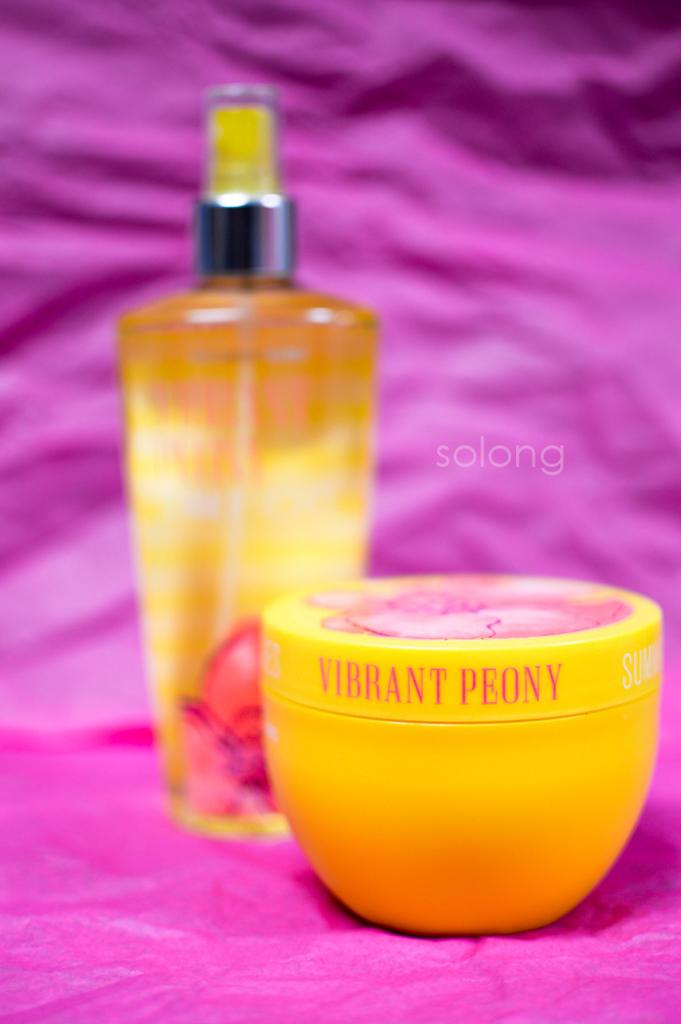<image>
Write a terse but informative summary of the picture. Jar of skin cream made by Vibrant Peony next to a bottle of spray. 